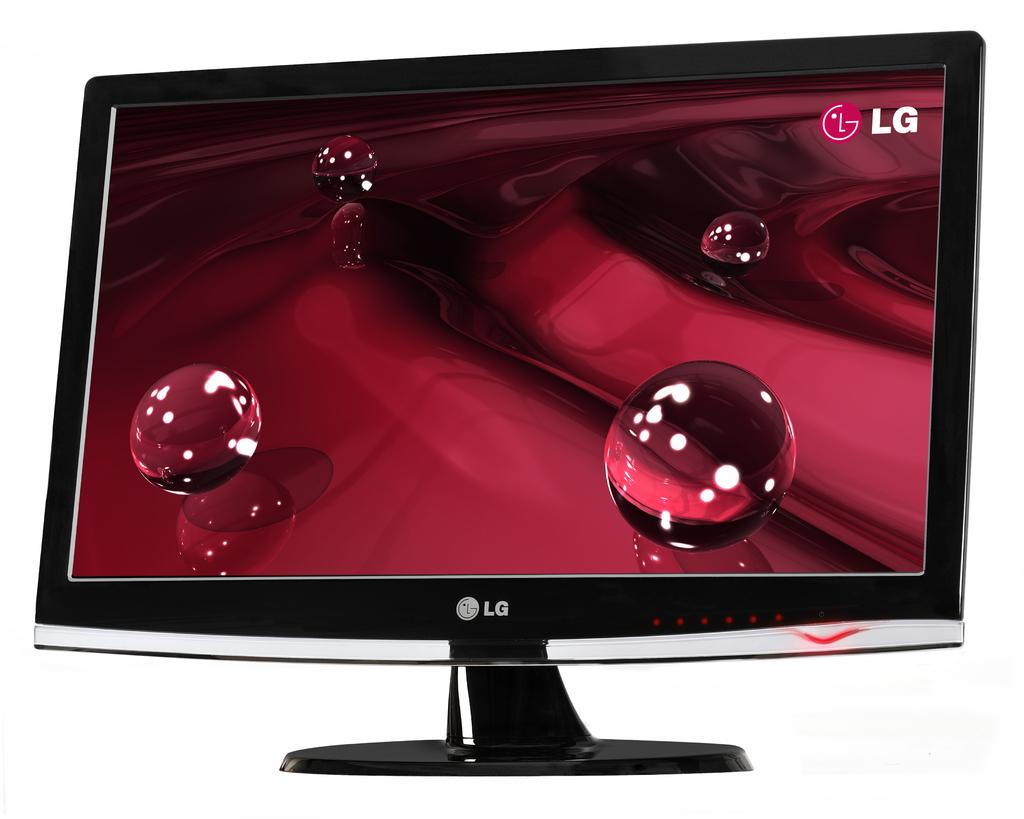Provide a one-sentence caption for the provided image. 4 clear marbles are on a rippling red surface, with the LG logo in the top right corner. 